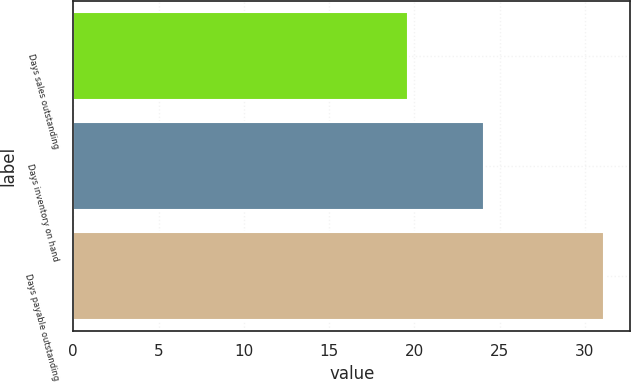Convert chart. <chart><loc_0><loc_0><loc_500><loc_500><bar_chart><fcel>Days sales outstanding<fcel>Days inventory on hand<fcel>Days payable outstanding<nl><fcel>19.6<fcel>24.1<fcel>31.1<nl></chart> 